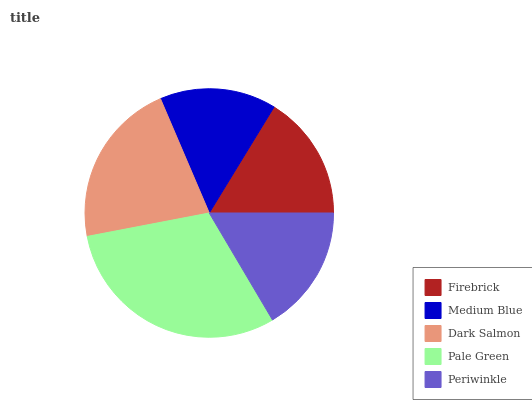Is Medium Blue the minimum?
Answer yes or no. Yes. Is Pale Green the maximum?
Answer yes or no. Yes. Is Dark Salmon the minimum?
Answer yes or no. No. Is Dark Salmon the maximum?
Answer yes or no. No. Is Dark Salmon greater than Medium Blue?
Answer yes or no. Yes. Is Medium Blue less than Dark Salmon?
Answer yes or no. Yes. Is Medium Blue greater than Dark Salmon?
Answer yes or no. No. Is Dark Salmon less than Medium Blue?
Answer yes or no. No. Is Periwinkle the high median?
Answer yes or no. Yes. Is Periwinkle the low median?
Answer yes or no. Yes. Is Pale Green the high median?
Answer yes or no. No. Is Medium Blue the low median?
Answer yes or no. No. 